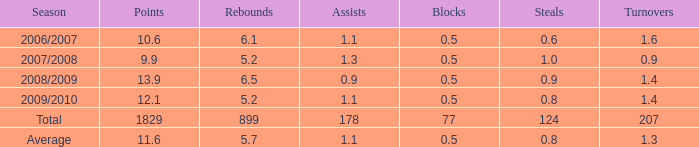What is the greatest rebounds when there are None. 